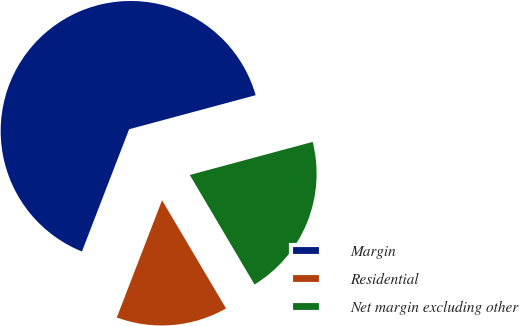<chart> <loc_0><loc_0><loc_500><loc_500><pie_chart><fcel>Margin<fcel>Residential<fcel>Net margin excluding other<nl><fcel>64.95%<fcel>14.36%<fcel>20.69%<nl></chart> 